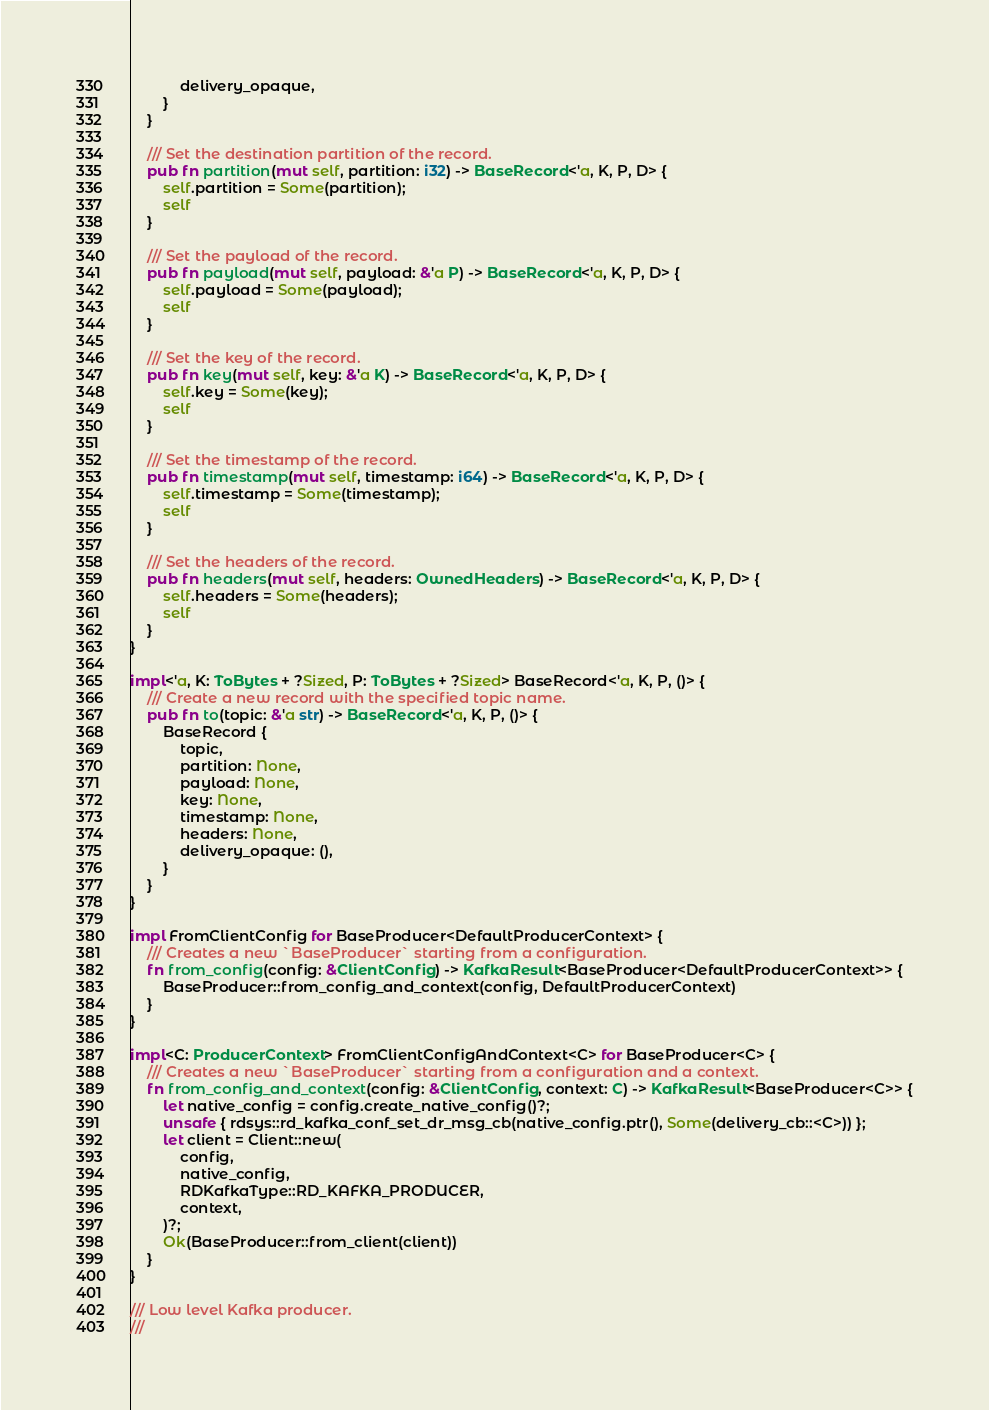<code> <loc_0><loc_0><loc_500><loc_500><_Rust_>            delivery_opaque,
        }
    }

    /// Set the destination partition of the record.
    pub fn partition(mut self, partition: i32) -> BaseRecord<'a, K, P, D> {
        self.partition = Some(partition);
        self
    }

    /// Set the payload of the record.
    pub fn payload(mut self, payload: &'a P) -> BaseRecord<'a, K, P, D> {
        self.payload = Some(payload);
        self
    }

    /// Set the key of the record.
    pub fn key(mut self, key: &'a K) -> BaseRecord<'a, K, P, D> {
        self.key = Some(key);
        self
    }

    /// Set the timestamp of the record.
    pub fn timestamp(mut self, timestamp: i64) -> BaseRecord<'a, K, P, D> {
        self.timestamp = Some(timestamp);
        self
    }

    /// Set the headers of the record.
    pub fn headers(mut self, headers: OwnedHeaders) -> BaseRecord<'a, K, P, D> {
        self.headers = Some(headers);
        self
    }
}

impl<'a, K: ToBytes + ?Sized, P: ToBytes + ?Sized> BaseRecord<'a, K, P, ()> {
    /// Create a new record with the specified topic name.
    pub fn to(topic: &'a str) -> BaseRecord<'a, K, P, ()> {
        BaseRecord {
            topic,
            partition: None,
            payload: None,
            key: None,
            timestamp: None,
            headers: None,
            delivery_opaque: (),
        }
    }
}

impl FromClientConfig for BaseProducer<DefaultProducerContext> {
    /// Creates a new `BaseProducer` starting from a configuration.
    fn from_config(config: &ClientConfig) -> KafkaResult<BaseProducer<DefaultProducerContext>> {
        BaseProducer::from_config_and_context(config, DefaultProducerContext)
    }
}

impl<C: ProducerContext> FromClientConfigAndContext<C> for BaseProducer<C> {
    /// Creates a new `BaseProducer` starting from a configuration and a context.
    fn from_config_and_context(config: &ClientConfig, context: C) -> KafkaResult<BaseProducer<C>> {
        let native_config = config.create_native_config()?;
        unsafe { rdsys::rd_kafka_conf_set_dr_msg_cb(native_config.ptr(), Some(delivery_cb::<C>)) };
        let client = Client::new(
            config,
            native_config,
            RDKafkaType::RD_KAFKA_PRODUCER,
            context,
        )?;
        Ok(BaseProducer::from_client(client))
    }
}

/// Low level Kafka producer.
///</code> 